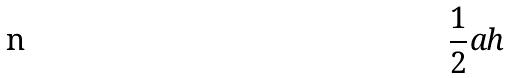Convert formula to latex. <formula><loc_0><loc_0><loc_500><loc_500>\frac { 1 } { 2 } a h</formula> 